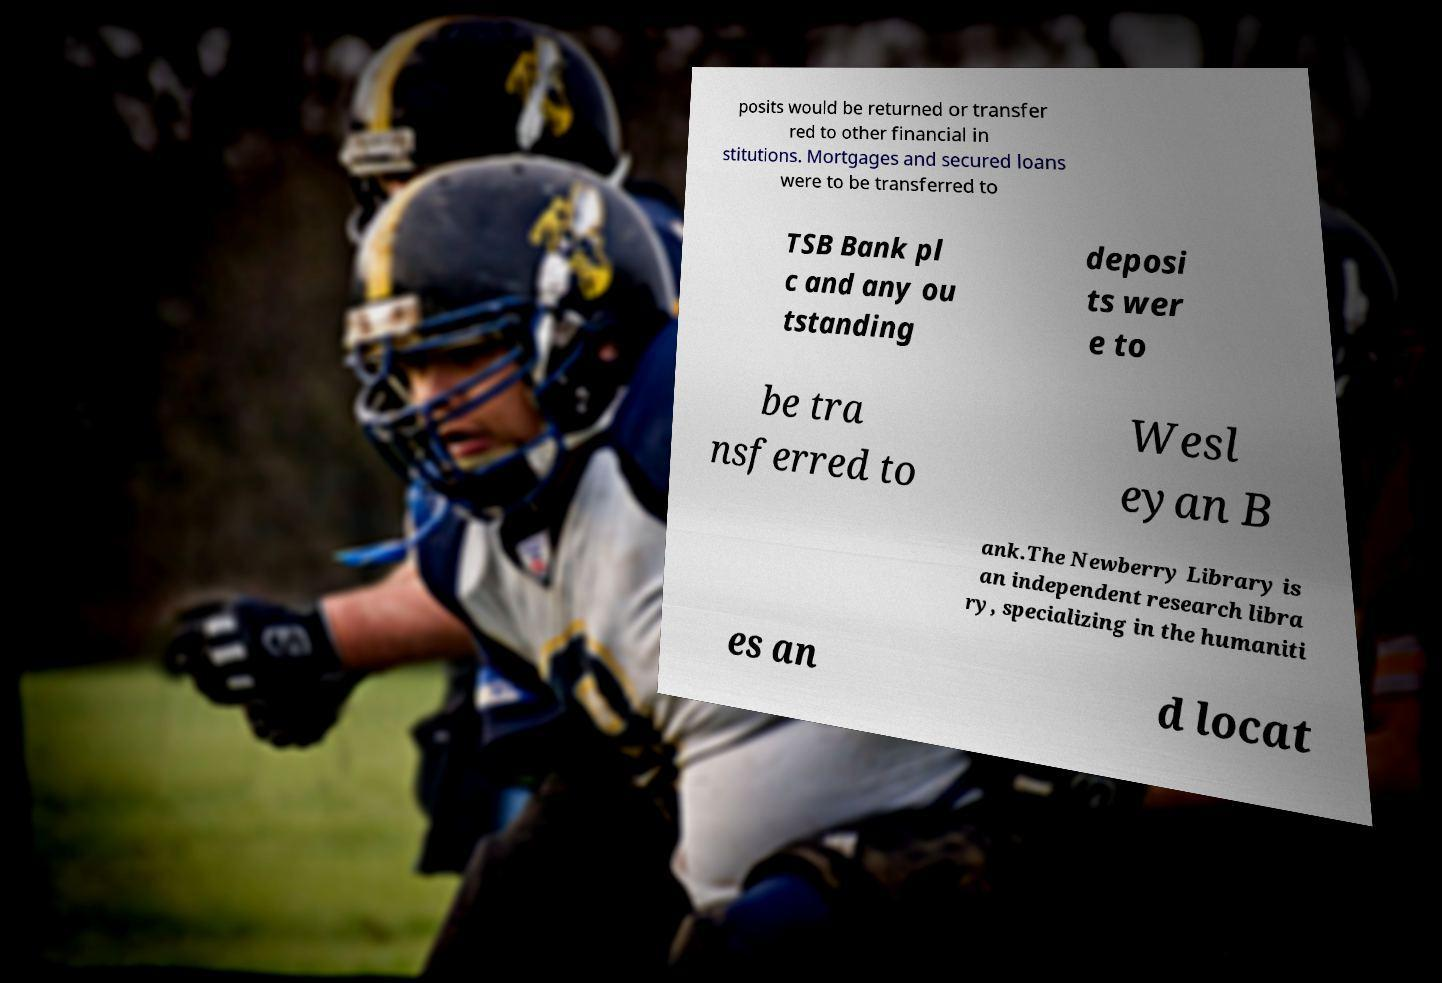Could you extract and type out the text from this image? posits would be returned or transfer red to other financial in stitutions. Mortgages and secured loans were to be transferred to TSB Bank pl c and any ou tstanding deposi ts wer e to be tra nsferred to Wesl eyan B ank.The Newberry Library is an independent research libra ry, specializing in the humaniti es an d locat 